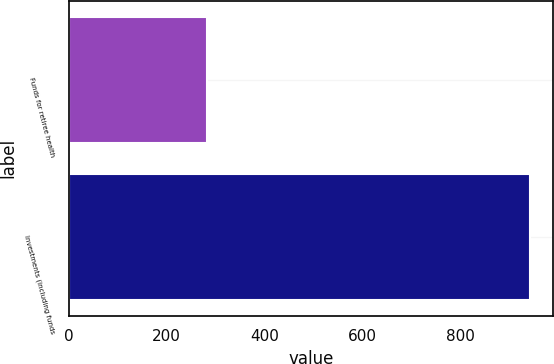Convert chart. <chart><loc_0><loc_0><loc_500><loc_500><bar_chart><fcel>Funds for retiree health<fcel>Investments (including funds<nl><fcel>282<fcel>942<nl></chart> 